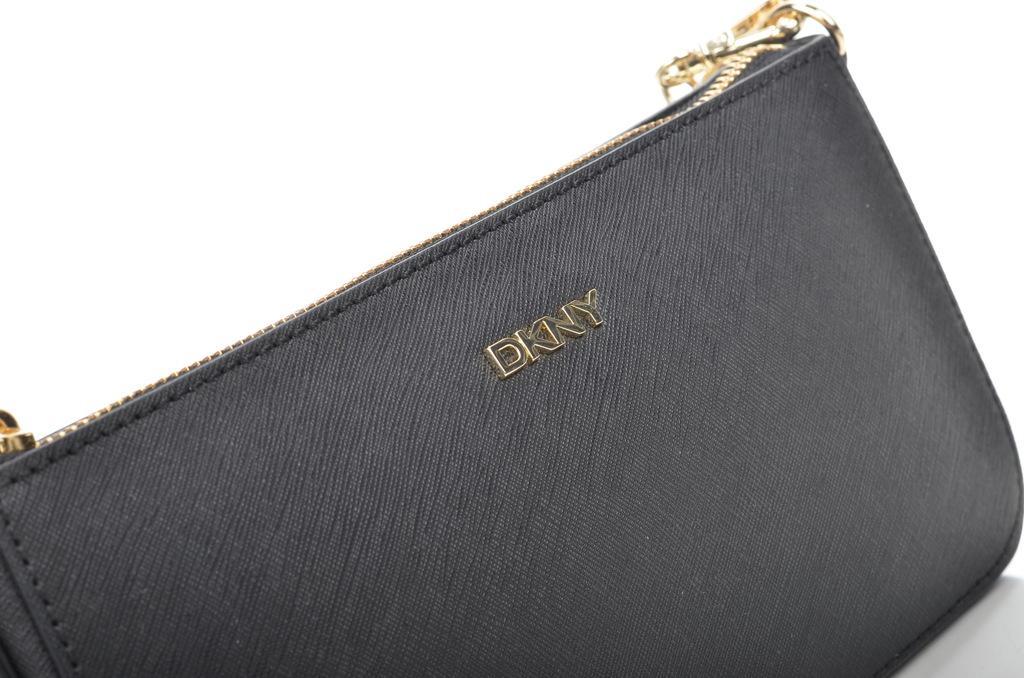Please provide a concise description of this image. In the picture there is a black color bag with a golden color zip the brand name written on the bag is "DKNY" in the background there is a white color wall. 